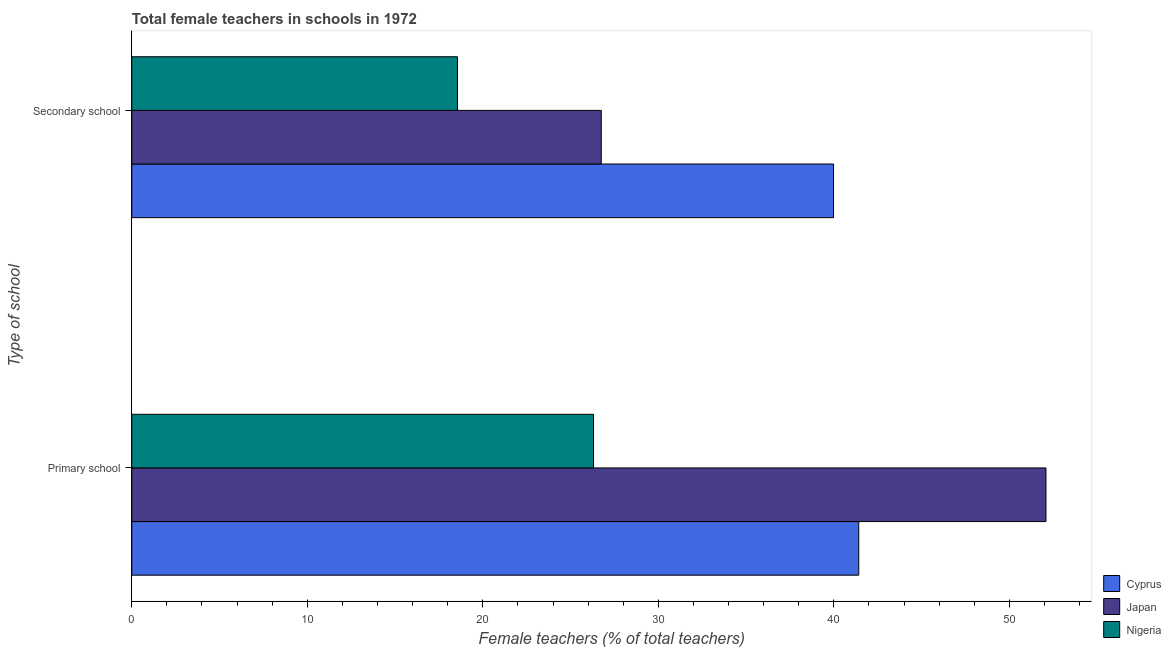What is the label of the 1st group of bars from the top?
Ensure brevity in your answer.  Secondary school. What is the percentage of female teachers in primary schools in Cyprus?
Your answer should be compact. 41.42. Across all countries, what is the maximum percentage of female teachers in secondary schools?
Offer a terse response. 39.98. Across all countries, what is the minimum percentage of female teachers in secondary schools?
Make the answer very short. 18.56. In which country was the percentage of female teachers in primary schools minimum?
Your answer should be very brief. Nigeria. What is the total percentage of female teachers in secondary schools in the graph?
Keep it short and to the point. 85.29. What is the difference between the percentage of female teachers in primary schools in Nigeria and that in Japan?
Provide a succinct answer. -25.78. What is the difference between the percentage of female teachers in primary schools in Japan and the percentage of female teachers in secondary schools in Cyprus?
Ensure brevity in your answer.  12.1. What is the average percentage of female teachers in secondary schools per country?
Provide a succinct answer. 28.43. What is the difference between the percentage of female teachers in primary schools and percentage of female teachers in secondary schools in Japan?
Keep it short and to the point. 25.34. In how many countries, is the percentage of female teachers in primary schools greater than 10 %?
Your answer should be compact. 3. What is the ratio of the percentage of female teachers in secondary schools in Cyprus to that in Nigeria?
Provide a short and direct response. 2.15. Is the percentage of female teachers in secondary schools in Japan less than that in Cyprus?
Keep it short and to the point. Yes. In how many countries, is the percentage of female teachers in secondary schools greater than the average percentage of female teachers in secondary schools taken over all countries?
Ensure brevity in your answer.  1. What does the 3rd bar from the bottom in Primary school represents?
Make the answer very short. Nigeria. Are all the bars in the graph horizontal?
Offer a terse response. Yes. How many countries are there in the graph?
Provide a short and direct response. 3. What is the difference between two consecutive major ticks on the X-axis?
Give a very brief answer. 10. Does the graph contain grids?
Provide a short and direct response. No. Where does the legend appear in the graph?
Give a very brief answer. Bottom right. What is the title of the graph?
Give a very brief answer. Total female teachers in schools in 1972. What is the label or title of the X-axis?
Give a very brief answer. Female teachers (% of total teachers). What is the label or title of the Y-axis?
Your answer should be very brief. Type of school. What is the Female teachers (% of total teachers) of Cyprus in Primary school?
Give a very brief answer. 41.42. What is the Female teachers (% of total teachers) of Japan in Primary school?
Offer a terse response. 52.08. What is the Female teachers (% of total teachers) in Nigeria in Primary school?
Provide a short and direct response. 26.31. What is the Female teachers (% of total teachers) of Cyprus in Secondary school?
Your response must be concise. 39.98. What is the Female teachers (% of total teachers) of Japan in Secondary school?
Make the answer very short. 26.75. What is the Female teachers (% of total teachers) of Nigeria in Secondary school?
Keep it short and to the point. 18.56. Across all Type of school, what is the maximum Female teachers (% of total teachers) of Cyprus?
Your answer should be compact. 41.42. Across all Type of school, what is the maximum Female teachers (% of total teachers) of Japan?
Your response must be concise. 52.08. Across all Type of school, what is the maximum Female teachers (% of total teachers) in Nigeria?
Your answer should be compact. 26.31. Across all Type of school, what is the minimum Female teachers (% of total teachers) in Cyprus?
Your answer should be compact. 39.98. Across all Type of school, what is the minimum Female teachers (% of total teachers) of Japan?
Your response must be concise. 26.75. Across all Type of school, what is the minimum Female teachers (% of total teachers) of Nigeria?
Your response must be concise. 18.56. What is the total Female teachers (% of total teachers) of Cyprus in the graph?
Your answer should be very brief. 81.4. What is the total Female teachers (% of total teachers) of Japan in the graph?
Your answer should be compact. 78.83. What is the total Female teachers (% of total teachers) in Nigeria in the graph?
Offer a terse response. 44.86. What is the difference between the Female teachers (% of total teachers) in Cyprus in Primary school and that in Secondary school?
Provide a short and direct response. 1.44. What is the difference between the Female teachers (% of total teachers) in Japan in Primary school and that in Secondary school?
Provide a short and direct response. 25.34. What is the difference between the Female teachers (% of total teachers) of Nigeria in Primary school and that in Secondary school?
Keep it short and to the point. 7.75. What is the difference between the Female teachers (% of total teachers) in Cyprus in Primary school and the Female teachers (% of total teachers) in Japan in Secondary school?
Offer a very short reply. 14.67. What is the difference between the Female teachers (% of total teachers) in Cyprus in Primary school and the Female teachers (% of total teachers) in Nigeria in Secondary school?
Your answer should be very brief. 22.86. What is the difference between the Female teachers (% of total teachers) in Japan in Primary school and the Female teachers (% of total teachers) in Nigeria in Secondary school?
Offer a very short reply. 33.53. What is the average Female teachers (% of total teachers) in Cyprus per Type of school?
Offer a very short reply. 40.7. What is the average Female teachers (% of total teachers) of Japan per Type of school?
Offer a very short reply. 39.42. What is the average Female teachers (% of total teachers) of Nigeria per Type of school?
Your answer should be very brief. 22.43. What is the difference between the Female teachers (% of total teachers) in Cyprus and Female teachers (% of total teachers) in Japan in Primary school?
Offer a terse response. -10.67. What is the difference between the Female teachers (% of total teachers) in Cyprus and Female teachers (% of total teachers) in Nigeria in Primary school?
Offer a very short reply. 15.11. What is the difference between the Female teachers (% of total teachers) in Japan and Female teachers (% of total teachers) in Nigeria in Primary school?
Offer a terse response. 25.78. What is the difference between the Female teachers (% of total teachers) of Cyprus and Female teachers (% of total teachers) of Japan in Secondary school?
Make the answer very short. 13.23. What is the difference between the Female teachers (% of total teachers) of Cyprus and Female teachers (% of total teachers) of Nigeria in Secondary school?
Keep it short and to the point. 21.42. What is the difference between the Female teachers (% of total teachers) in Japan and Female teachers (% of total teachers) in Nigeria in Secondary school?
Make the answer very short. 8.19. What is the ratio of the Female teachers (% of total teachers) of Cyprus in Primary school to that in Secondary school?
Ensure brevity in your answer.  1.04. What is the ratio of the Female teachers (% of total teachers) in Japan in Primary school to that in Secondary school?
Your answer should be very brief. 1.95. What is the ratio of the Female teachers (% of total teachers) of Nigeria in Primary school to that in Secondary school?
Make the answer very short. 1.42. What is the difference between the highest and the second highest Female teachers (% of total teachers) of Cyprus?
Provide a succinct answer. 1.44. What is the difference between the highest and the second highest Female teachers (% of total teachers) in Japan?
Your response must be concise. 25.34. What is the difference between the highest and the second highest Female teachers (% of total teachers) in Nigeria?
Your answer should be very brief. 7.75. What is the difference between the highest and the lowest Female teachers (% of total teachers) in Cyprus?
Your response must be concise. 1.44. What is the difference between the highest and the lowest Female teachers (% of total teachers) in Japan?
Your answer should be very brief. 25.34. What is the difference between the highest and the lowest Female teachers (% of total teachers) in Nigeria?
Your answer should be very brief. 7.75. 